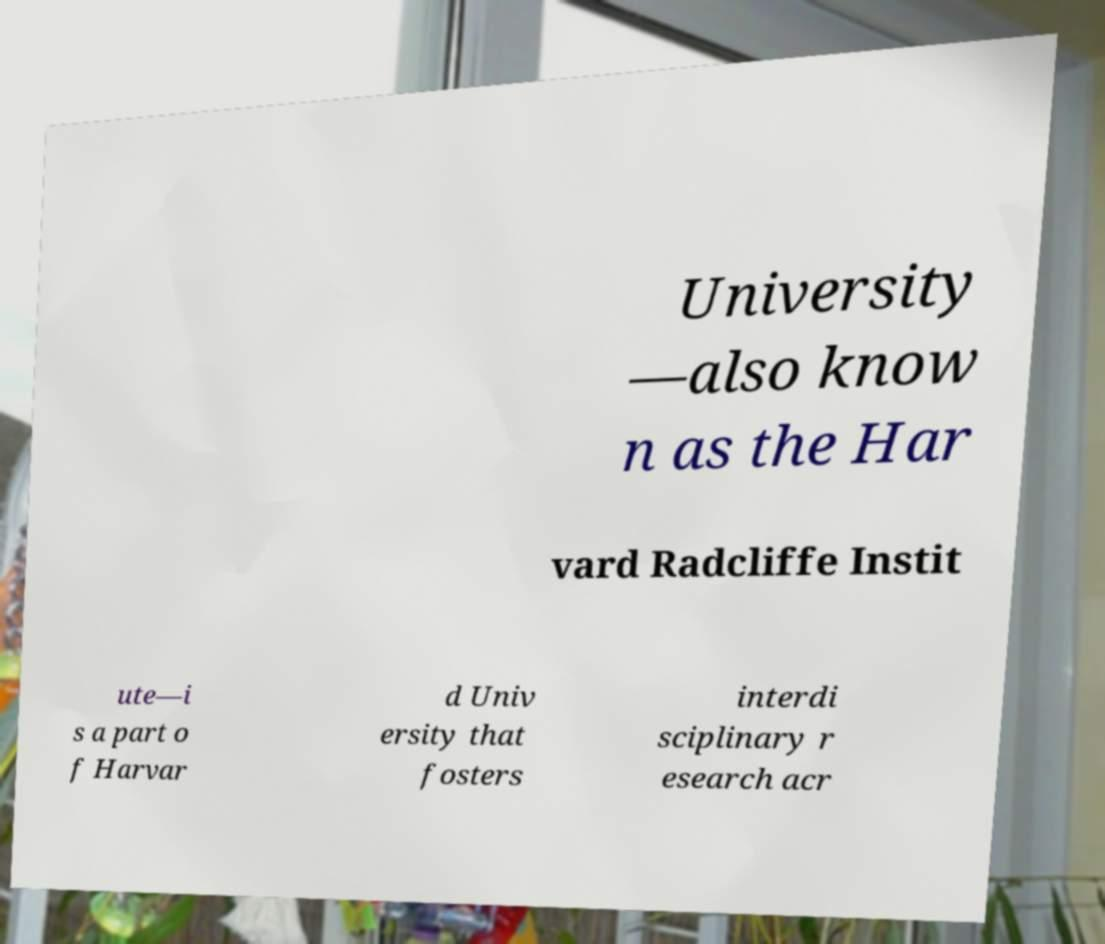Could you assist in decoding the text presented in this image and type it out clearly? University —also know n as the Har vard Radcliffe Instit ute—i s a part o f Harvar d Univ ersity that fosters interdi sciplinary r esearch acr 